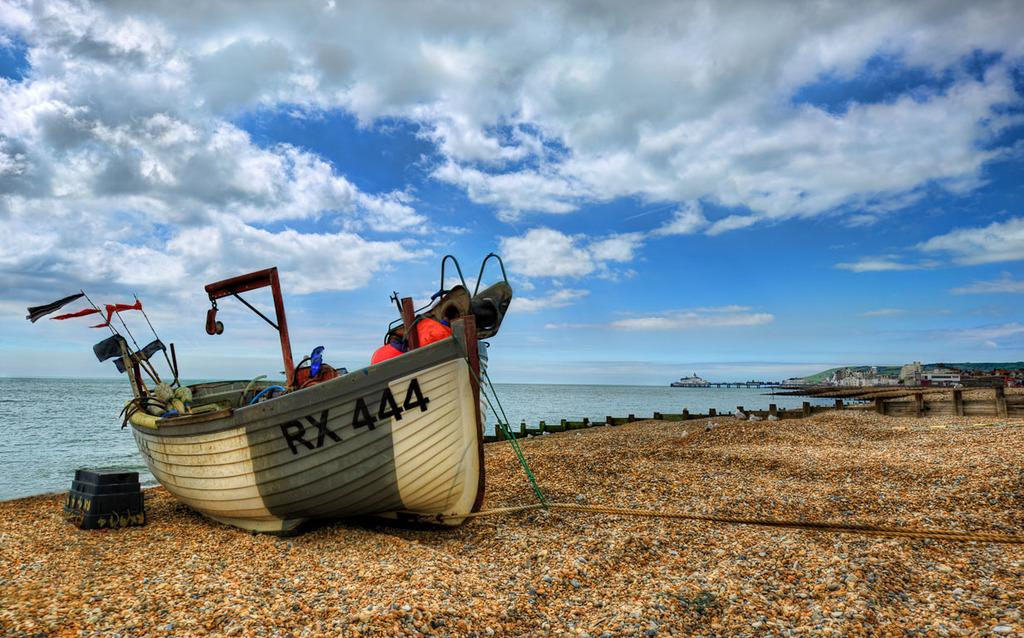Provide a one-sentence caption for the provided image. A boat sitting on the beach with the number RX 444 on the side. 